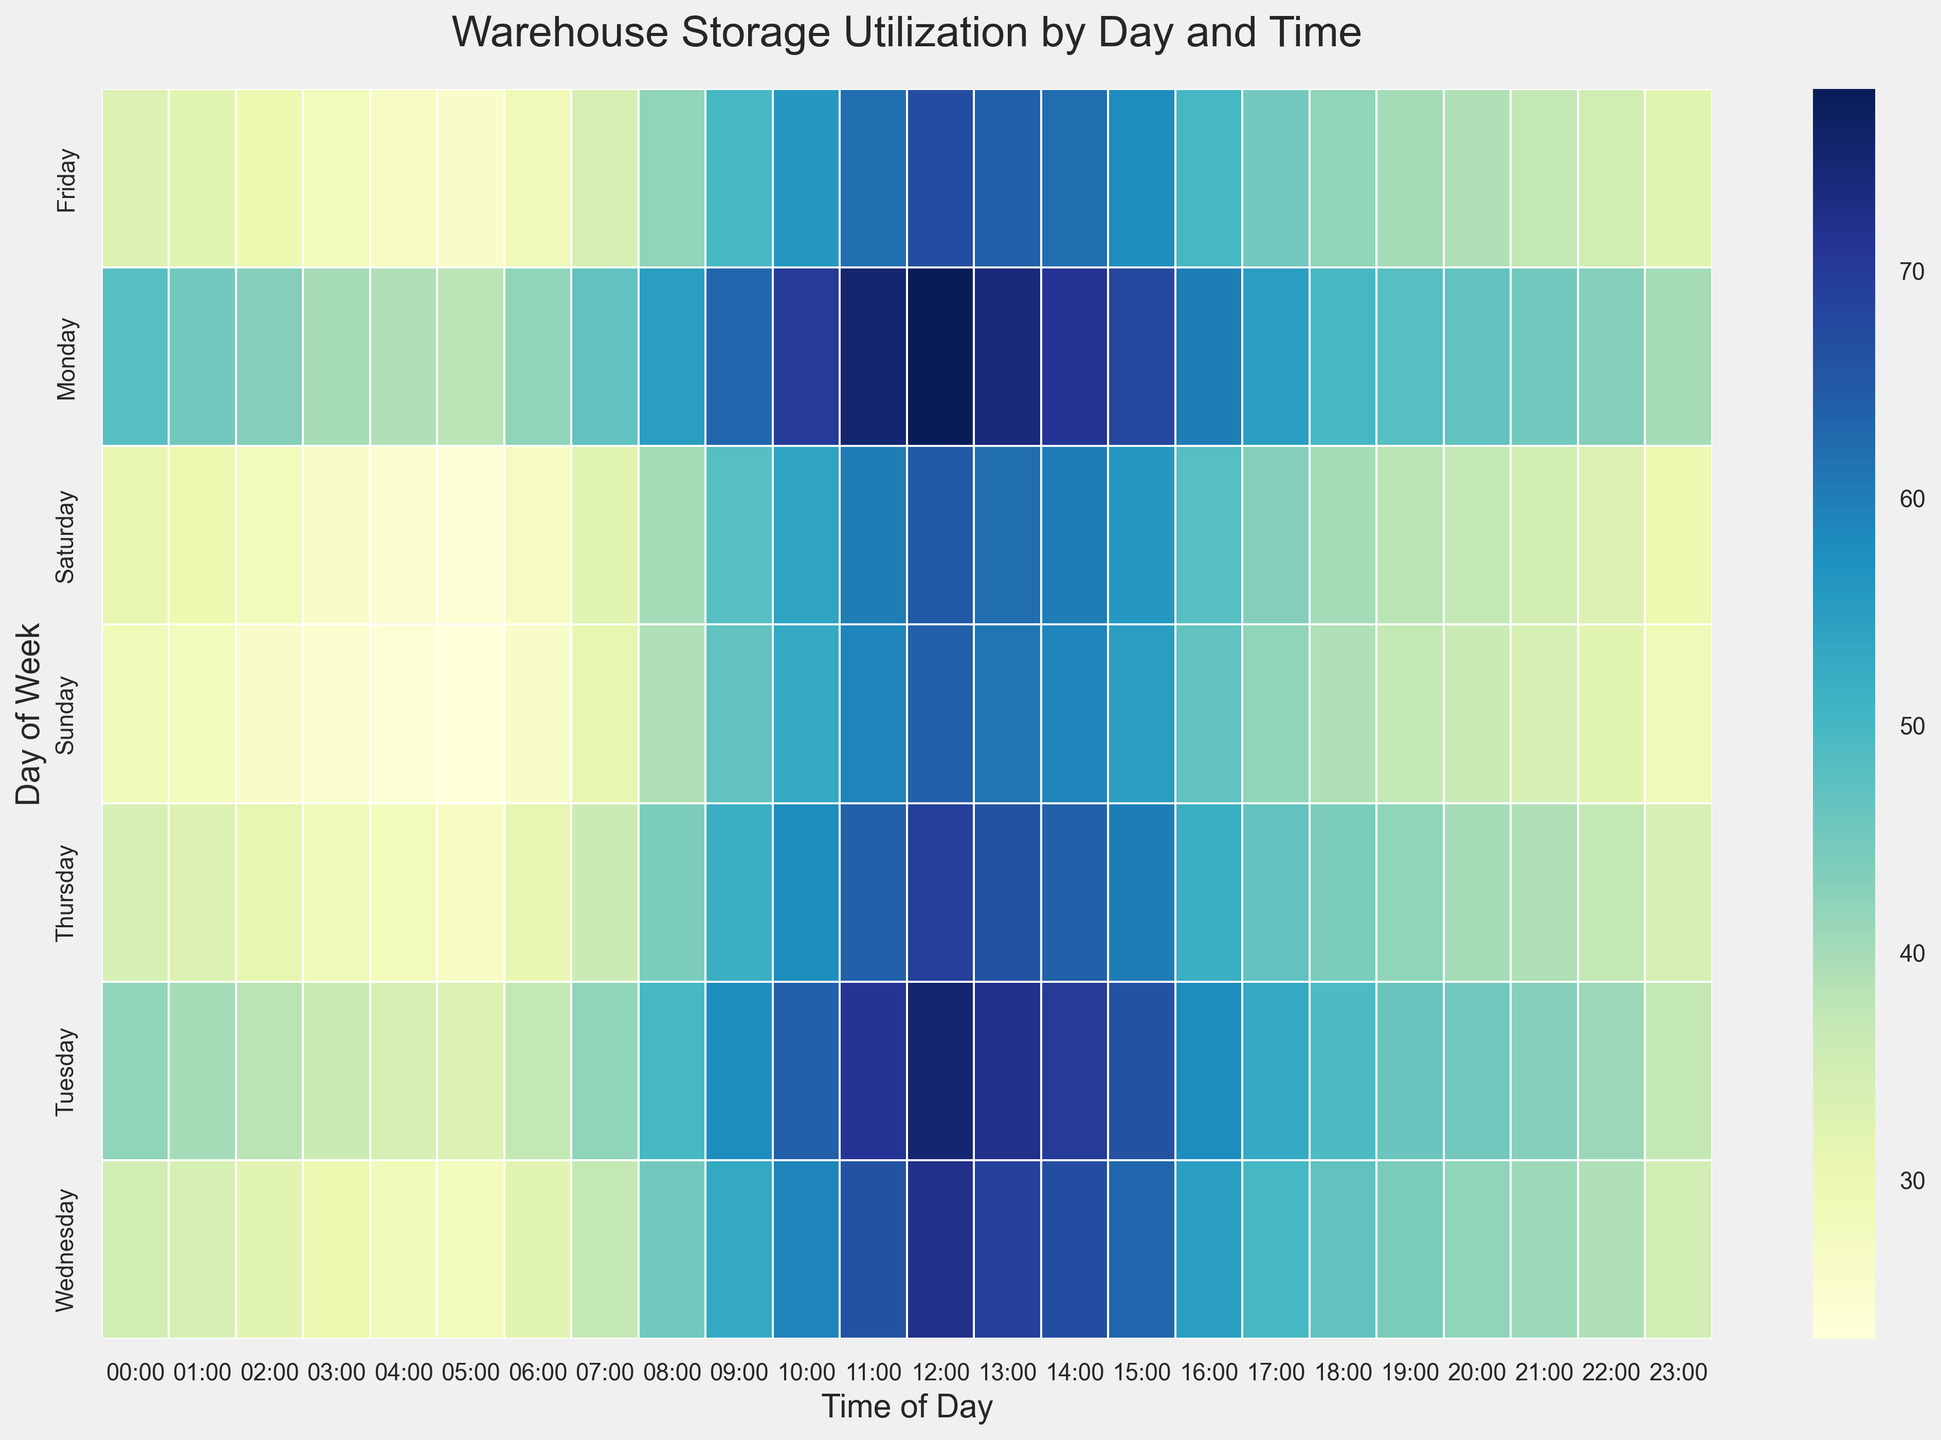Which day and time period has the highest storage utilization? By visually inspecting the heatmap, identify the cell with the darkest color, which indicates the highest utilization. The darkest cell is at Monday, 12:00.
Answer: Monday, 12:00 Which day shows the least variation in storage utilization throughout the day? Look for the day with the most uniform color distribution across its row on the heatmap. Wednesday shows a consistent distribution of utilization throughout the day.
Answer: Wednesday Comparing the storage utilization at 10:00 across all days of the week, which day has the lowest value? Check the heatmap column for "10:00" and find the day with the lightest color, indicating the lowest utilization. Sunday has the lowest utilization at 10:00.
Answer: Sunday What is the average storage utilization on Tuesday between 14:00 and 18:00? The time slots are 14:00, 15:00, 16:00, 17:00, and 18:00. The utilization values are 70, 66, 58, 53, and 49 respectively. Sum these values (70 + 66 + 58 + 53 + 49 = 296) and divide by the number of values (5) to get the average utilization (296/5 = 59.2).
Answer: 59.2 During which time period is storage utilization generally lowest across all days? Look for the column with the lightest overall color throughout the week. The time period 02:00 shows the lowest utilization consistently across most days.
Answer: 02:00 How does the storage utilization on Friday at 16:00 compare to the utilization on Sunday at the same time? Locate the cells for Friday at 16:00 and Sunday at 16:00 on the heatmap. The colors indicate that Friday has a utilization value of 50 and Sunday has a utilization value of 47.
Answer: Friday utilization is higher What is the total storage utilization on Wednesday between 08:00 and 12:00? The time slots are 08:00, 09:00, 10:00, 11:00, and 12:00. The utilization values are 45, 53, 59, 66, and 72 respectively. Sum these values to get the total utilization (45 + 53 + 59 + 66 + 72 = 295).
Answer: 295 Which day has a higher storage utilization at noon compared to the previous day? Compare storage utilization values at 12:00 for each day and the day before. For example, Tuesday (75) vs. Monday (78), and so on. Monday has a higher utilization at noon compared to Sunday.
Answer: Monday compared to Sunday Is there a day when the storage utilization never drops below 30 at any time? Check each row on the heatmap to ensure all values are 30 or higher. Monday is the only day where utilization never drops below 30.
Answer: Monday Comparing morning (08:00 - 12:00) and evening (18:00 - 22:00) on Saturday, which period has higher average storage utilization? Morning values: 40, 48, 54, 60, 65. Evening values: 40, 38, 37, 35, 33. Calculate the average for both: Morning (40+48+54+60+65)/5 = 53.4 and Evening (40+38+37+35+33)/5 = 36.6. The morning has a higher average utilization.
Answer: Morning 